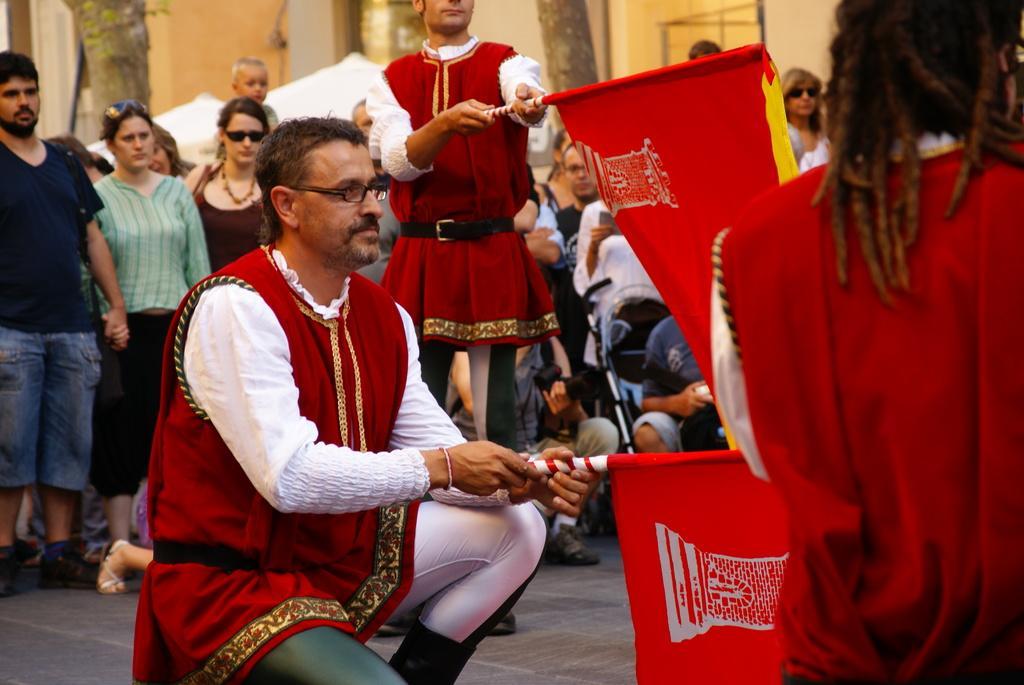Please provide a concise description of this image. This is a man sitting in squat position and holding a flag. There are group of people standing. These look like tree trunks. In the background, I can see a building. 